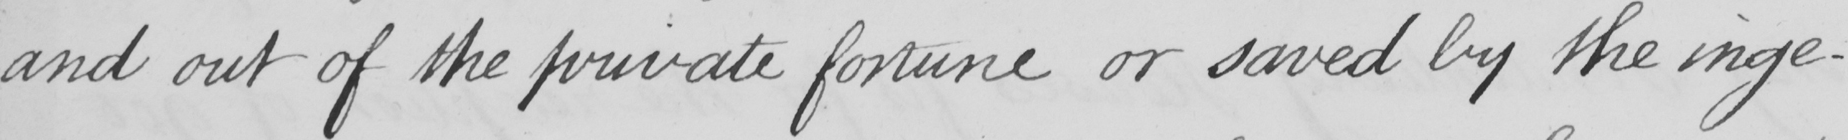Please transcribe the handwritten text in this image. and out of the private fortune or saved by the inge- 